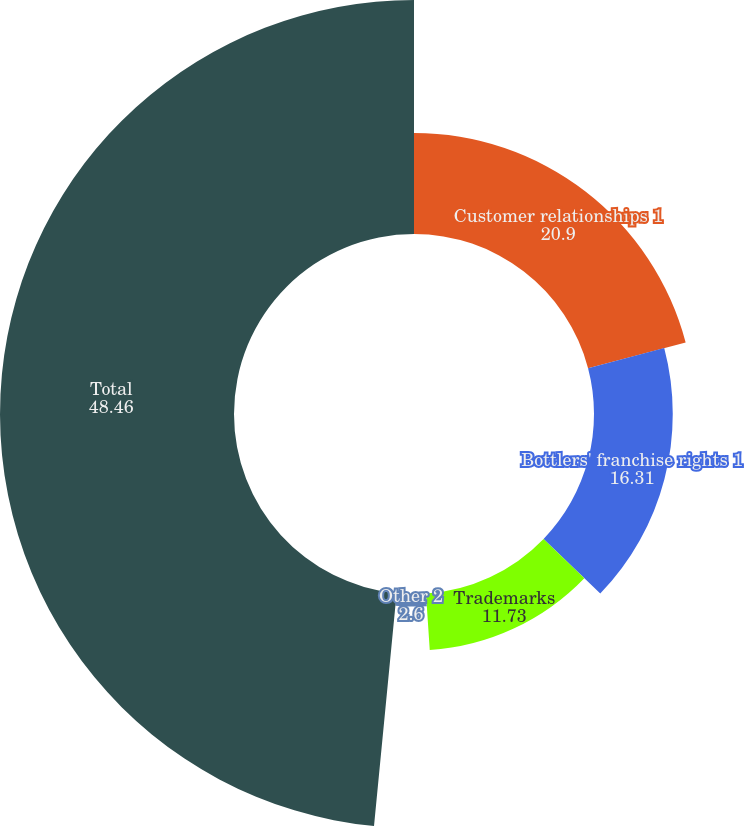Convert chart to OTSL. <chart><loc_0><loc_0><loc_500><loc_500><pie_chart><fcel>Customer relationships 1<fcel>Bottlers' franchise rights 1<fcel>Trademarks<fcel>Other 2<fcel>Total<nl><fcel>20.9%<fcel>16.31%<fcel>11.73%<fcel>2.6%<fcel>48.46%<nl></chart> 